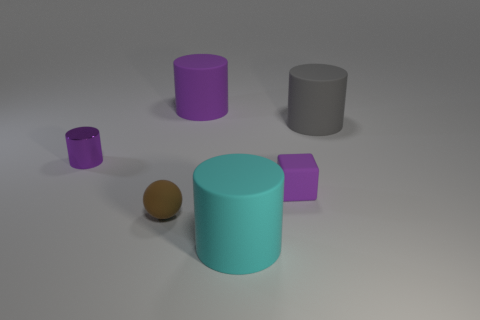What number of large cyan objects have the same material as the brown object?
Offer a very short reply. 1. How many things are small purple cylinders or big objects that are in front of the tiny brown matte thing?
Ensure brevity in your answer.  2. Is the material of the purple cylinder that is behind the gray thing the same as the big gray cylinder?
Make the answer very short. Yes. There is a sphere that is the same size as the purple rubber block; what is its color?
Provide a short and direct response. Brown. Is there a small purple metal object that has the same shape as the tiny brown rubber object?
Ensure brevity in your answer.  No. The large object that is in front of the small purple metal thing that is on the left side of the small purple thing on the right side of the small purple shiny cylinder is what color?
Make the answer very short. Cyan. How many metal objects are tiny brown things or gray cylinders?
Keep it short and to the point. 0. Are there more small purple shiny objects that are on the right side of the tiny brown sphere than large rubber cylinders that are in front of the shiny cylinder?
Your response must be concise. No. How many other things are the same size as the purple matte cylinder?
Ensure brevity in your answer.  2. There is a purple rubber object that is left of the large matte cylinder that is in front of the small metal cylinder; what size is it?
Make the answer very short. Large. 